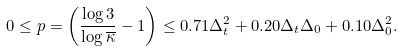<formula> <loc_0><loc_0><loc_500><loc_500>0 \leq p = \left ( \frac { \log 3 } { \log \overline { \kappa } } - 1 \right ) \leq 0 . 7 1 \Delta _ { t } ^ { 2 } + 0 . 2 0 \Delta _ { t } \Delta _ { 0 } + 0 . 1 0 \Delta _ { 0 } ^ { 2 } .</formula> 